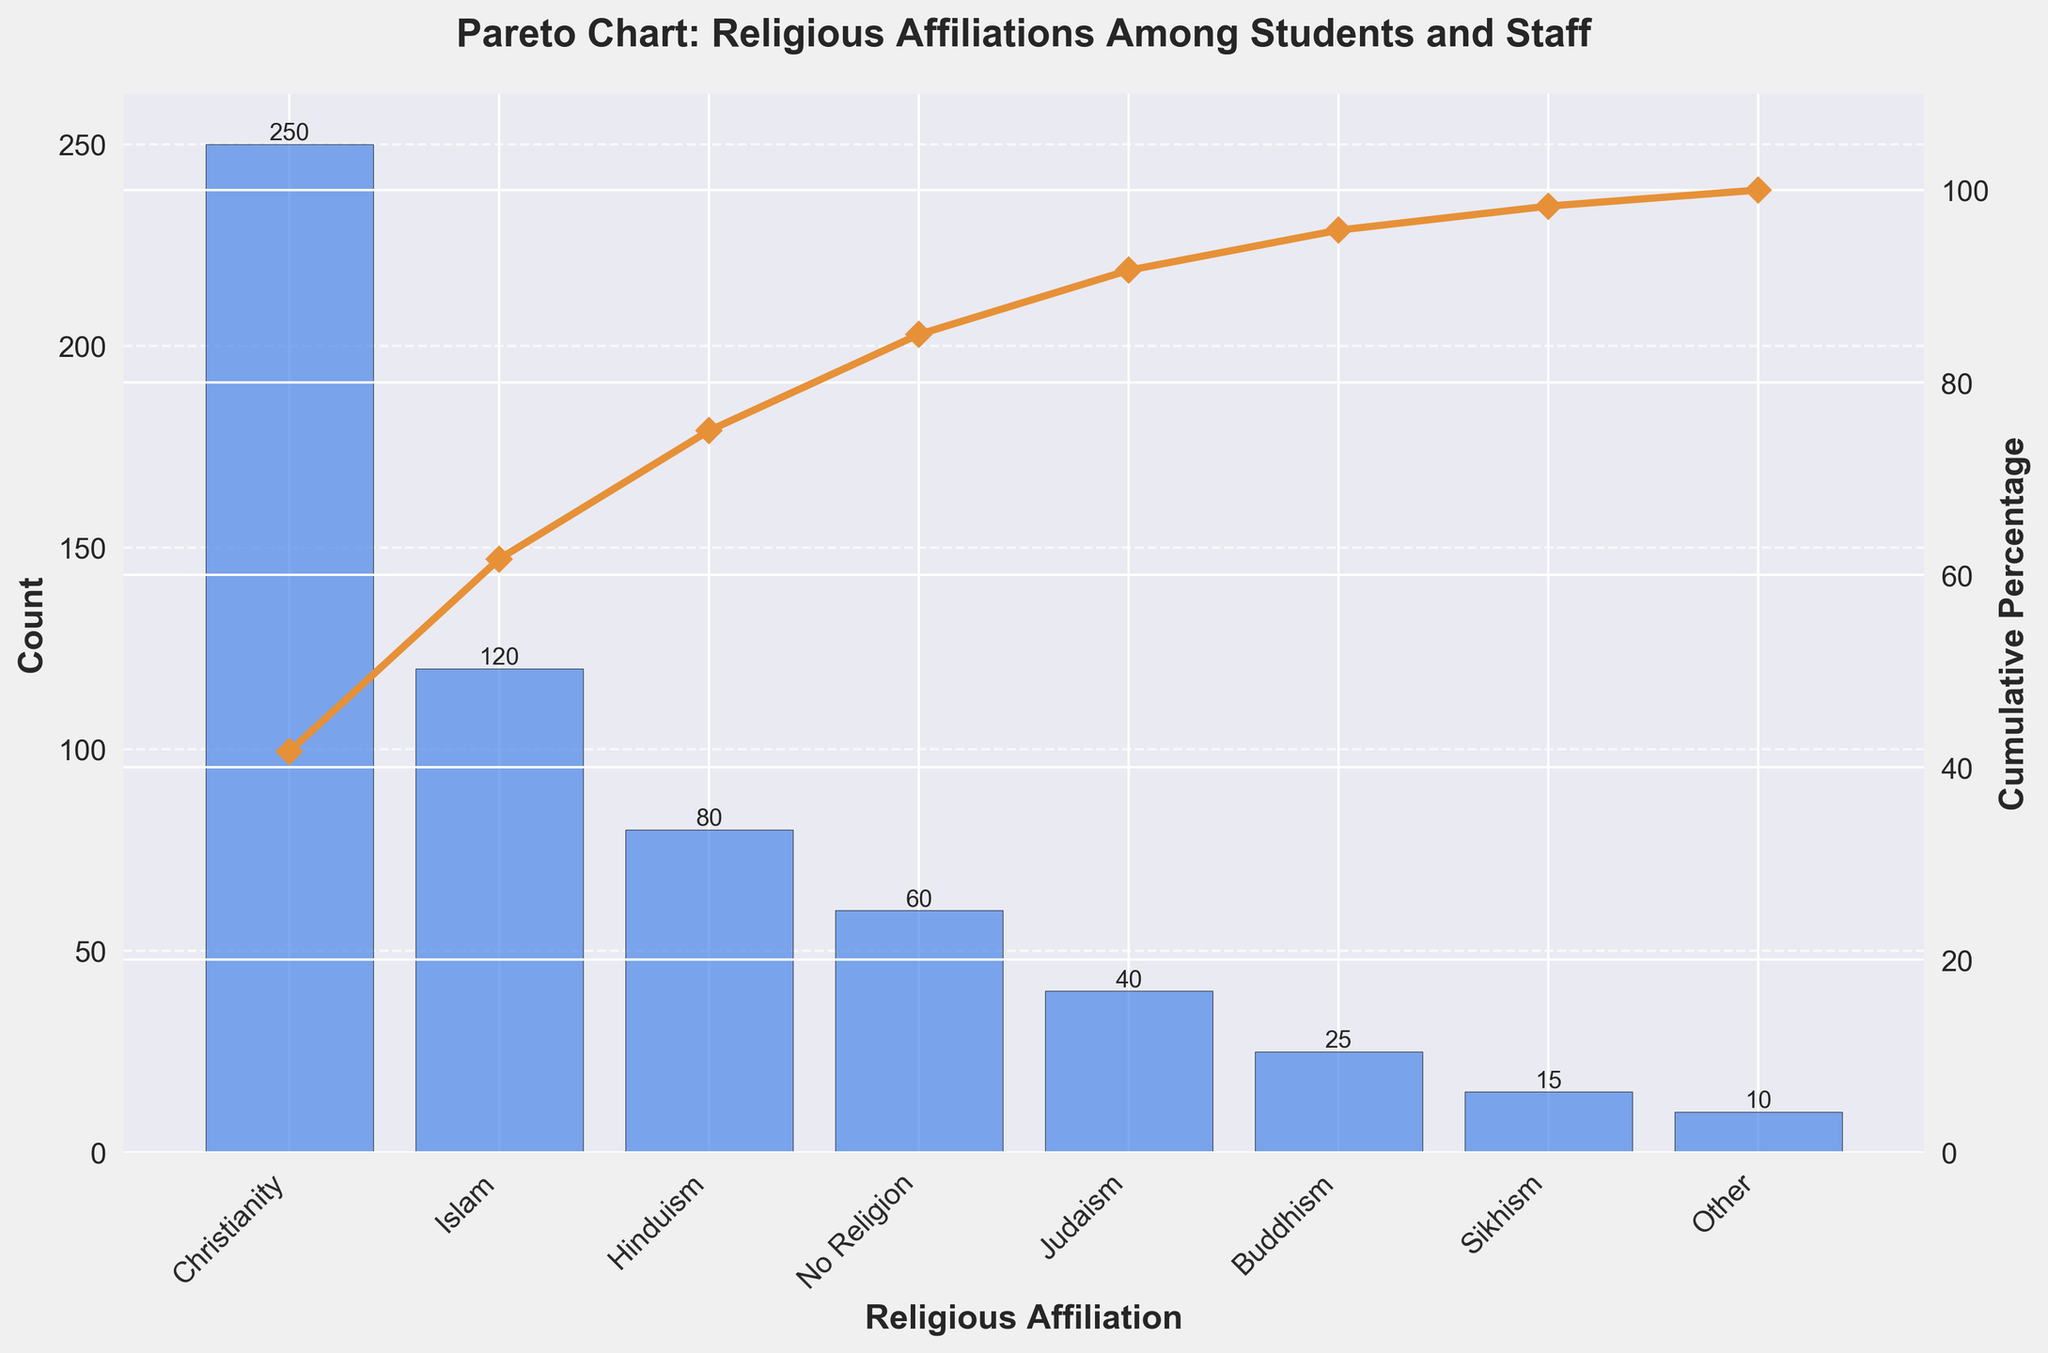What is the total count for Christianity? The bar representing Christianity shows the height of 250, which indicates the total count for Christianity.
Answer: 250 What is the cumulative percentage for Hinduism? The line plot shows the cumulative percentage for each religion. For Hinduism, the percentage is approximately at 82%.
Answer: 82% Which religious affiliation has the lowest count? The bar plot shows that "Other" has the shortest bar, indicating the lowest count.
Answer: Other How many religious affiliations are listed? The x-axis labels show eight different religious affiliations.
Answer: 8 What is the cumulative percentage after including Buddhism? The cumulative percentage line plot shows a value slightly above 95% after reaching Buddhism.
Answer: ~95% What is the difference in count between Christianity and Islam? The bar for Christianity is at 250, and the bar for Islam is at 120. The difference is 250 - 120.
Answer: 130 Which two religious affiliations together sum up to more than half of the total count? Christianity (250) and Islam (120) together make 370, which is more than the half of the total 600 (sum of all counts).
Answer: Christianity and Islam What percentage of the total does Judaism represent? Judaism has a count of 40. Total count is 600. Percentage is (40 / 600) * 100.
Answer: ~6.67% Which religious affiliations fall under the 80% cumulative percentage? From the line plot: Christianity, Islam, Hinduism fall under the 80% cumulative mark.
Answer: Christianity, Islam, Hinduism What is the cumulative percentage after adding Sikhism? The line plot shows the cumulative percentage just before reaching 100% after adding Sikhism.
Answer: ~99% 